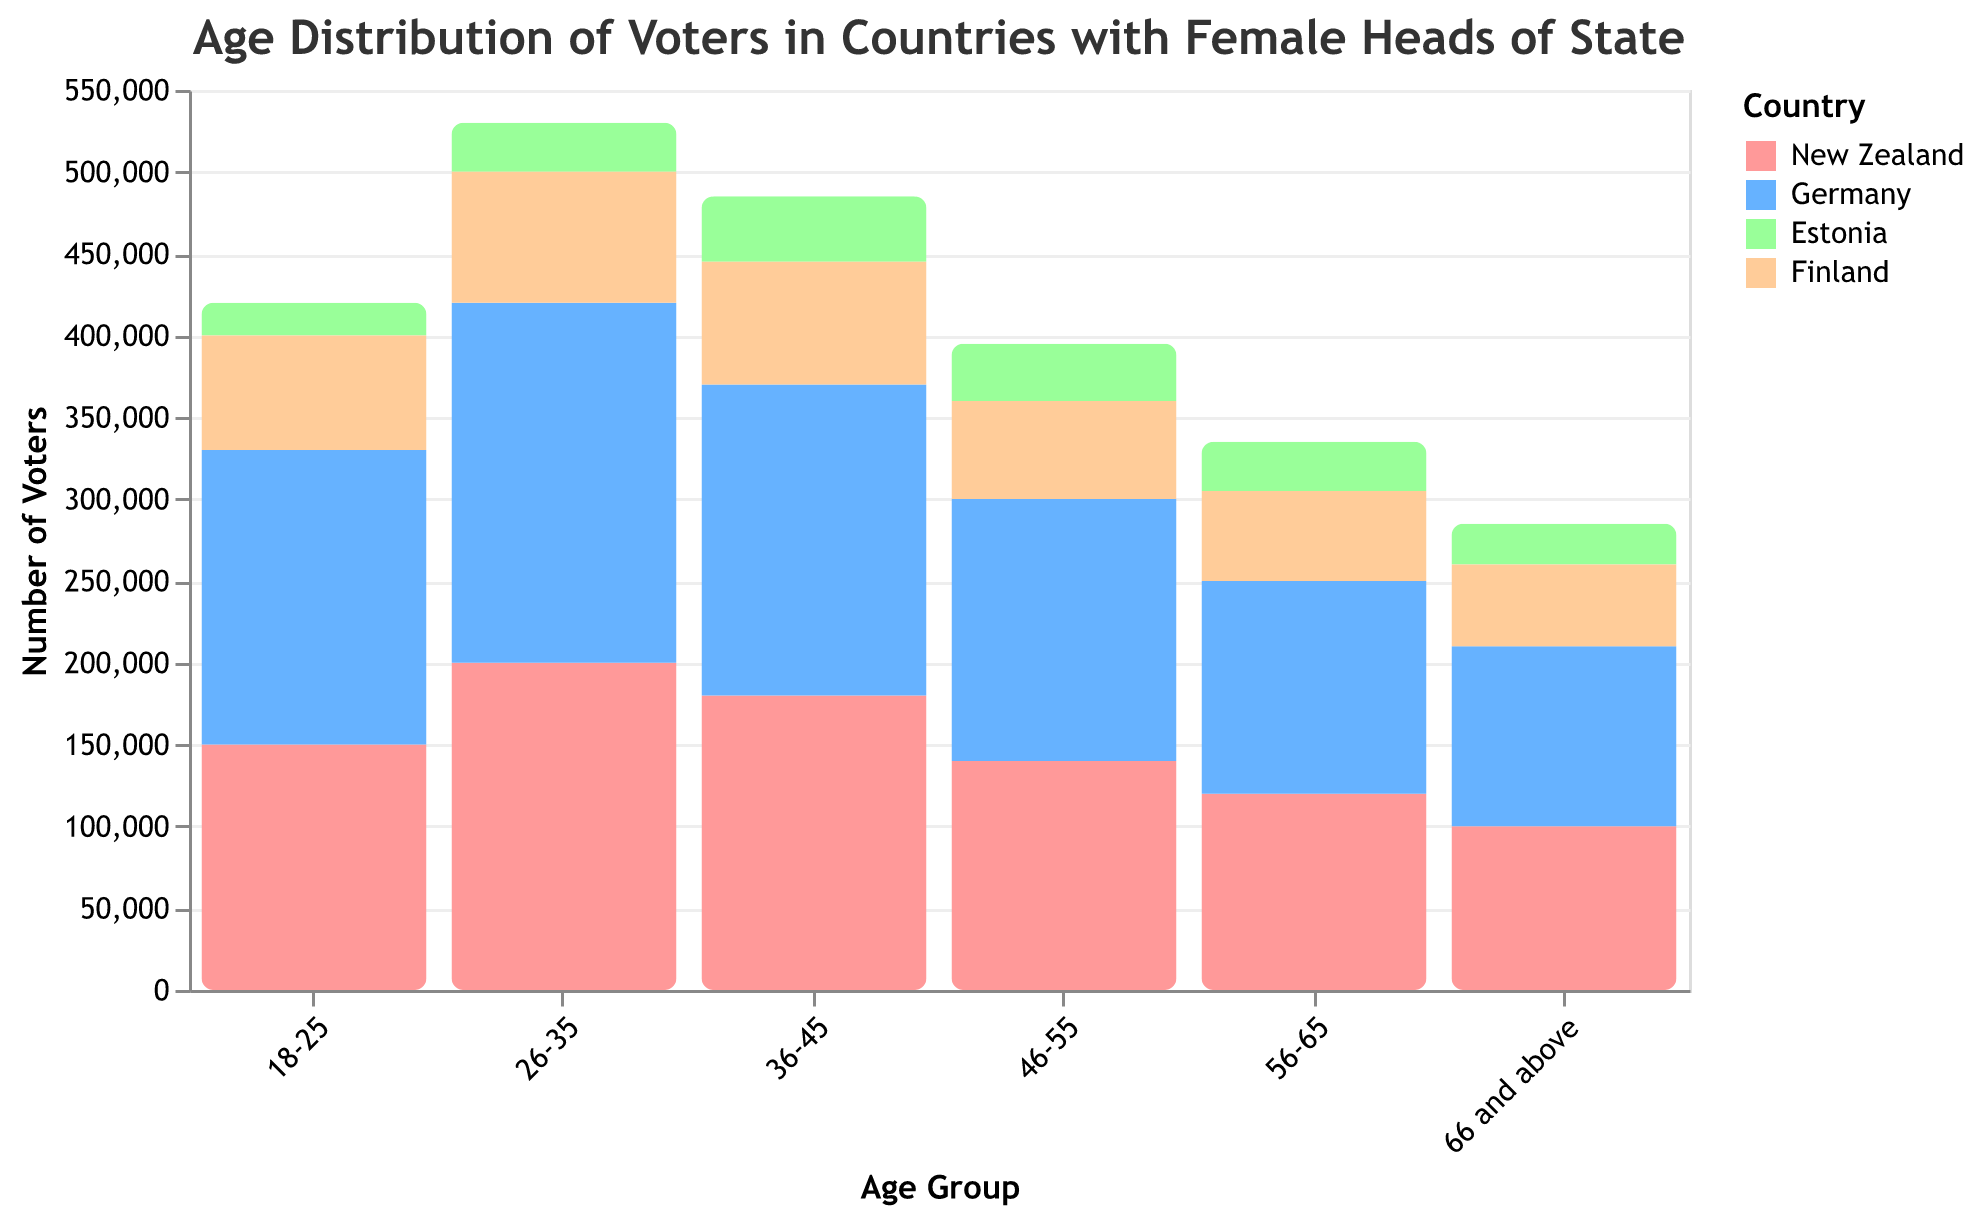What's the most common age group of voters in New Zealand? From the figure, locate the bar with the highest value for "Number of Voters" under the color representing New Zealand. The highest bar corresponds to the age group 26-35, indicating it's the most common age group of voters in New Zealand.
Answer: 26-35 Which country has the least number of voters in the 18-25 age group? Identify the bars representing the 18-25 age group for each country by their colors and observe their heights. Estonia has the shortest bar for this age group.
Answer: Estonia How many total voters are there in Germany? Sum the "Number of Voters" for all age groups in Germany: 180000 + 220000 + 190000 + 160000 + 130000 + 110000 = 990000.
Answer: 990000 What is the difference in the number of voters between the age groups 46-55 and 66 and above in Finland? Find the "Number of Voters" for Finland's 46-55 and 66 and above age groups from the corresponding bars' heights: 60000 - 50000 = 10000.
Answer: 10000 Which country has the highest number of voters in the 26-35 age group? Compare the heights of the bars representing the 26-35 age group for all countries by their respective colors. Germany has the highest bar in this age group.
Answer: Germany Is the number of voters in the 56-65 age group in New Zealand greater than in Estonia? Compare the bars representing the 56-65 age group in New Zealand and Estonia by their heights. New Zealand's bar is taller than Estonia's.
Answer: Yes What is the average number of voters in the 36-45 age group across all countries? Add the "Number of Voters" for the 36-45 age group for all countries and divide by the number of countries: (180000 + 190000 + 40000 + 75000) / 4 = 121250.
Answer: 121250 Between which two countries is the difference in the number of voters in the 66 and above age group the greatest? Observe the bars representing the 66 and above age group for all countries, then calculate differences: Germany (110000) - Estonia (25000) = 85000. Germany and Estonia show the largest difference.
Answer: Germany and Estonia In which age group does New Zealand have a higher number of voters than Finland? Compare the heights of the bars for each age group between New Zealand and Finland. New Zealand has a higher number of voters in all age groups except for the 18-25 and 26-35 age groups.
Answer: 36-45, 46-55, 56-65, 66 and above 